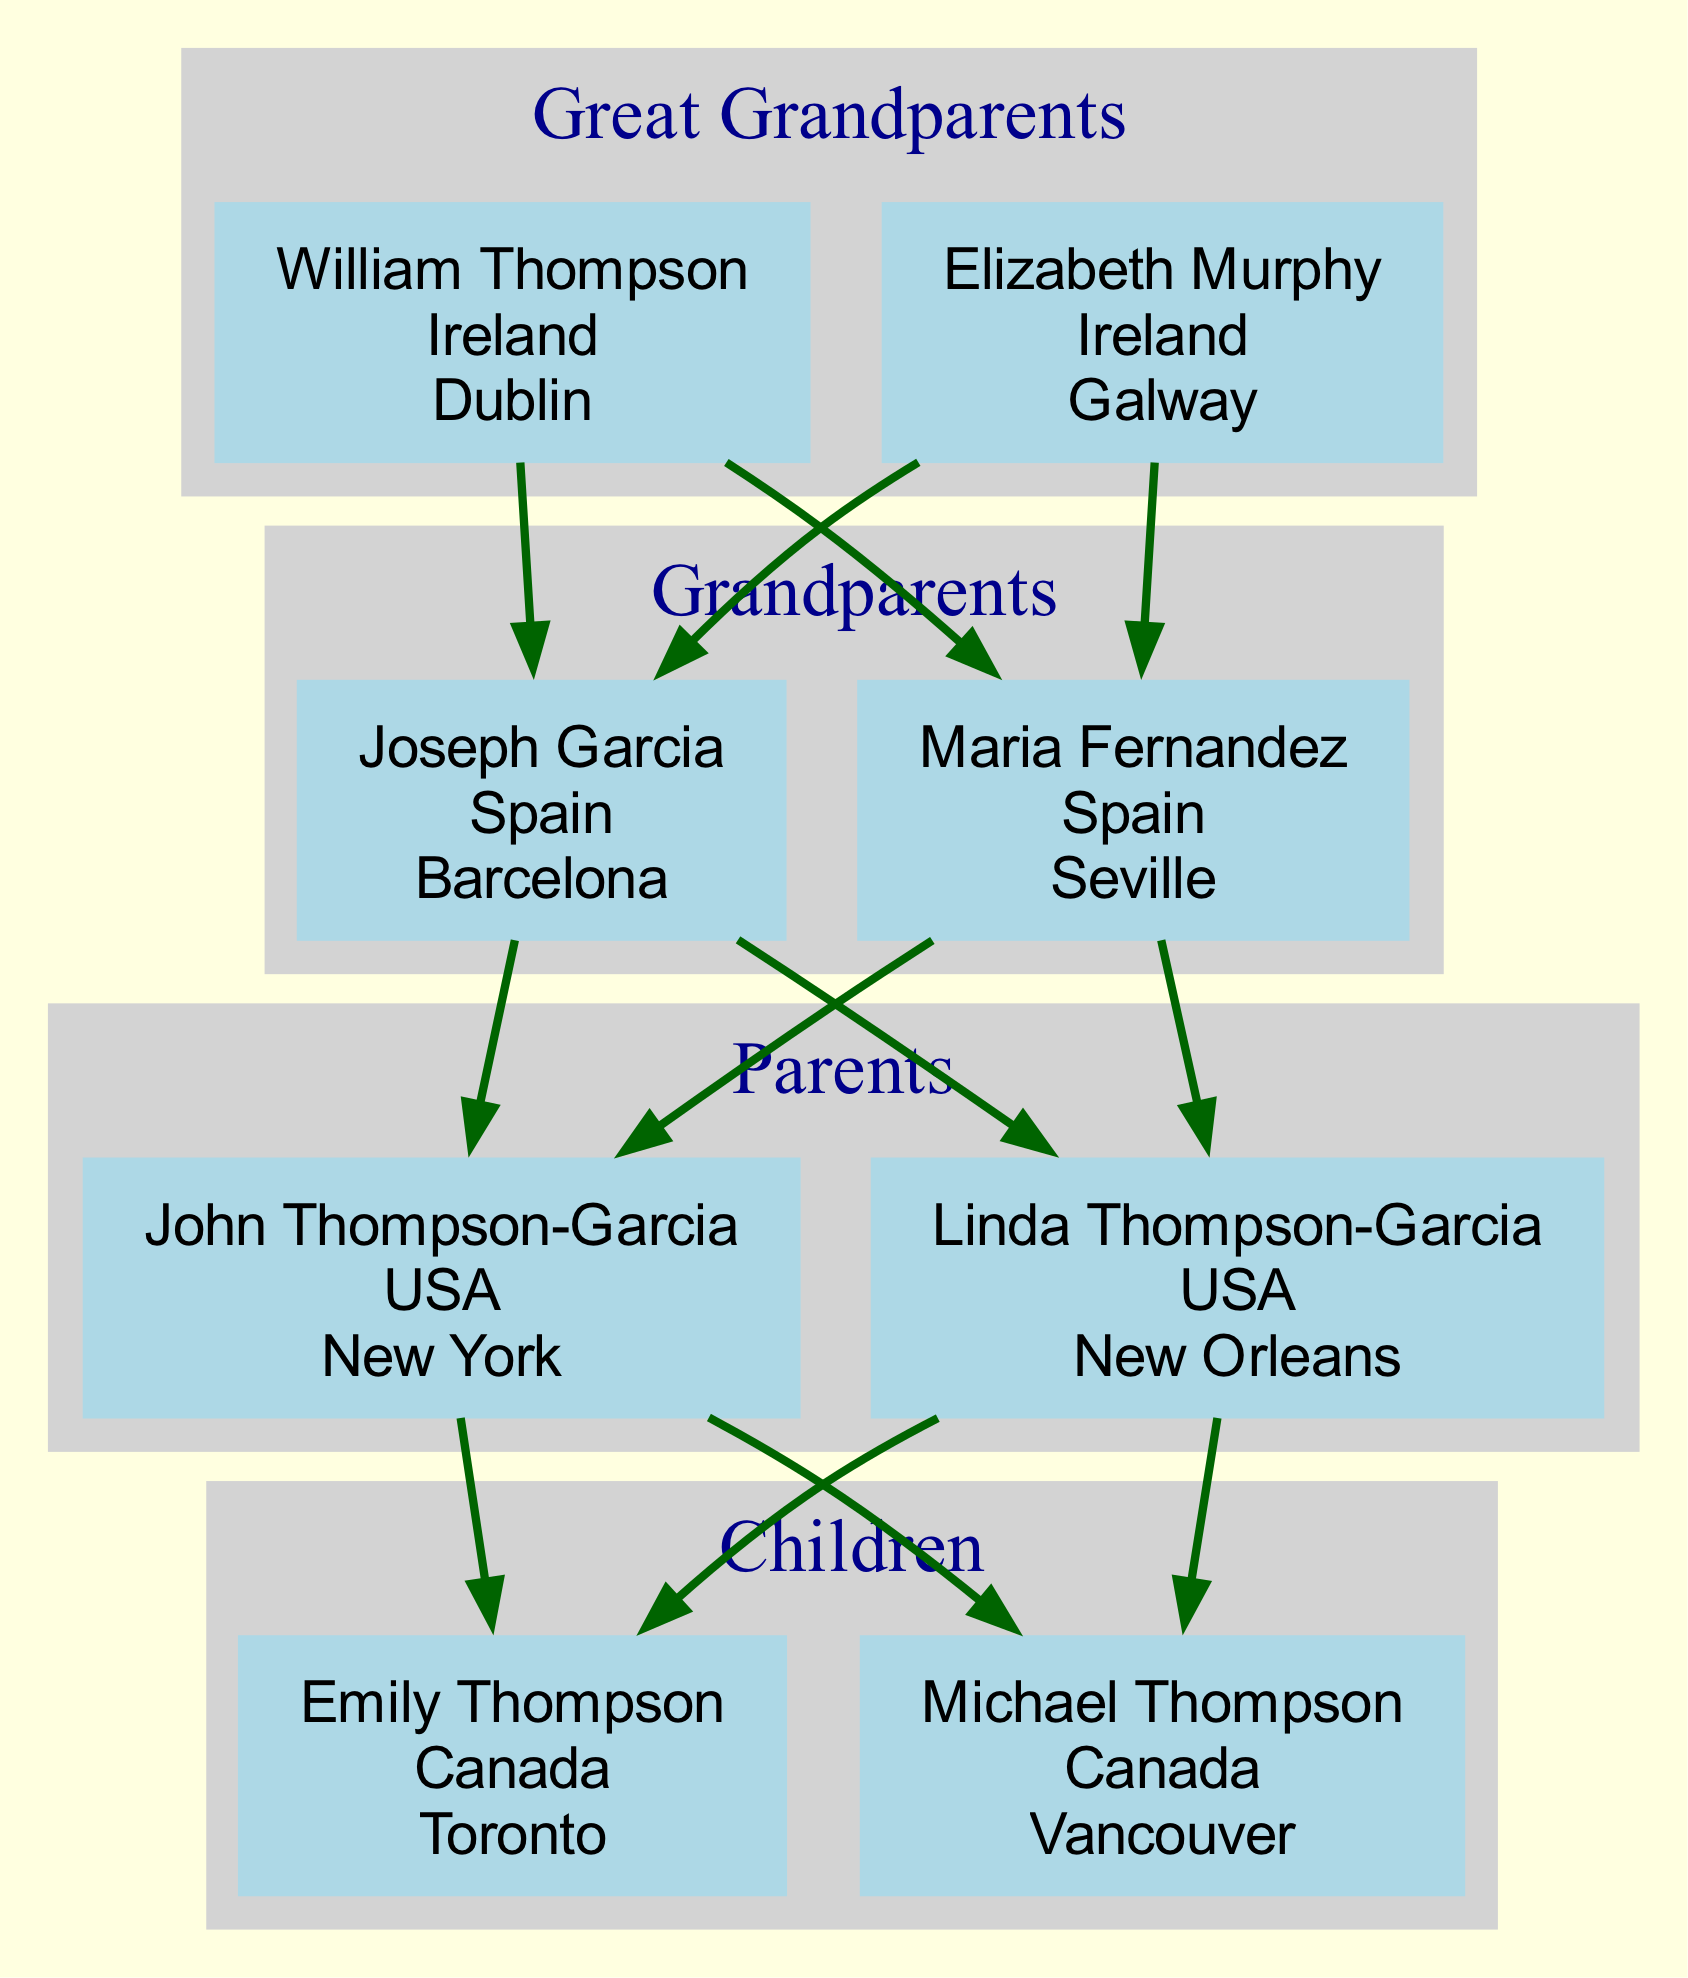What is the Key Ancestral Destination of William Thompson? The diagram clearly indicates that William Thompson's Key Ancestral Destination is Dublin. The information is presented directly under his name in the diagram.
Answer: Dublin How many generations are represented in the family tree? The diagram features a total of four generations: Great Grandparents, Grandparents, Parents, and Children. This is discerned by counting the distinct groups labeled in the diagram.
Answer: 4 Which city is the Key Ancestral Destination for the parent named Linda Thompson-Garcia? According to the diagram, Linda Thompson-Garcia’s Key Ancestral Destination is New Orleans, as noted in her section of the tree.
Answer: New Orleans Who are the Grandparents from Spain? The diagram specifies that the Grandparents from Spain are Joseph Garcia and Maria Fernandez. This is found in the Grandparents' section of the diagram that is labeled as belonging to Spain.
Answer: Joseph Garcia, Maria Fernandez Which member from the Children generation has Vancouver as a Key Ancestral Destination? The diagram indicates that Michael Thompson, part of the Children generation, has Vancouver as his Key Ancestral Destination, which is listed directly below his name.
Answer: Michael Thompson How many members are in the Great Grandparents generation? The diagram shows that there are two members in the Great Grandparents generation: William Thompson and Elizabeth Murphy. Counting these entries leads to the answer.
Answer: 2 Which generation has the Key Ancestral Destination of Barcelona? The Key Ancestral Destination of Barcelona belongs to Joseph Garcia, who is in the Grandparents generation. This information is found under his name in the diagram.
Answer: Grandparents From which place does Emily Thompson hail? The diagram makes it clear that Emily Thompson was born in Canada, which is specifically detailed next to her name in the Children generation.
Answer: Canada What is the Key Ancestral Destination associated with Joseph Garcia? According to the diagram, the Key Ancestral Destination associated with Joseph Garcia is Barcelona, as noted in his detailed information found directly in the Grandparents section.
Answer: Barcelona 